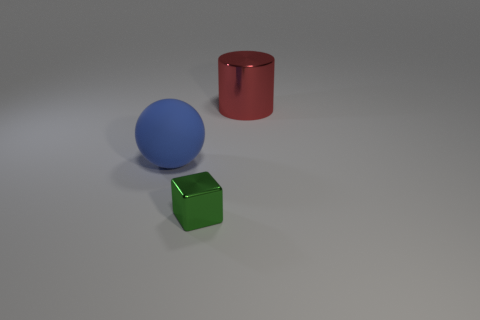Add 2 large shiny objects. How many objects exist? 5 Subtract 1 cylinders. How many cylinders are left? 0 Add 2 tiny metal blocks. How many tiny metal blocks exist? 3 Subtract 0 cyan cylinders. How many objects are left? 3 Subtract all spheres. How many objects are left? 2 Subtract all gray spheres. Subtract all brown cubes. How many spheres are left? 1 Subtract all brown blocks. How many purple spheres are left? 0 Subtract all tiny green shiny cubes. Subtract all balls. How many objects are left? 1 Add 2 green metal objects. How many green metal objects are left? 3 